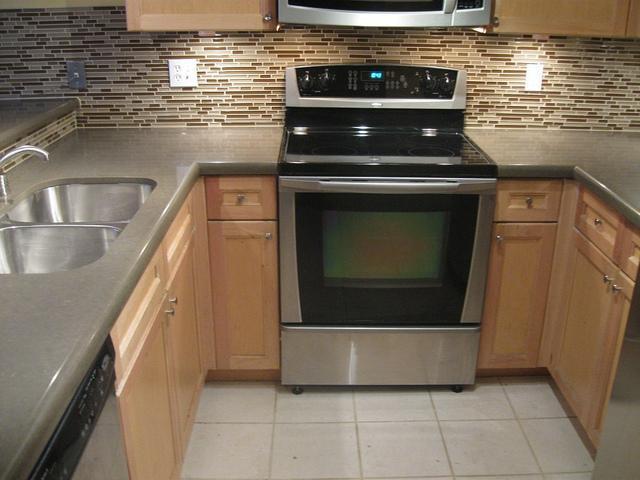How many people have on a helmet?
Give a very brief answer. 0. 